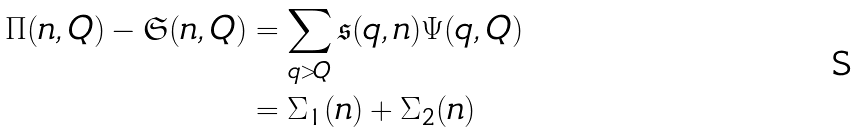<formula> <loc_0><loc_0><loc_500><loc_500>\Pi ( n , Q ) - \mathfrak S ( n , Q ) & = \sum _ { q > Q } \mathfrak s ( q , n ) \Psi ( q , Q ) \\ & = \Sigma _ { 1 } ( n ) + \Sigma _ { 2 } ( n )</formula> 